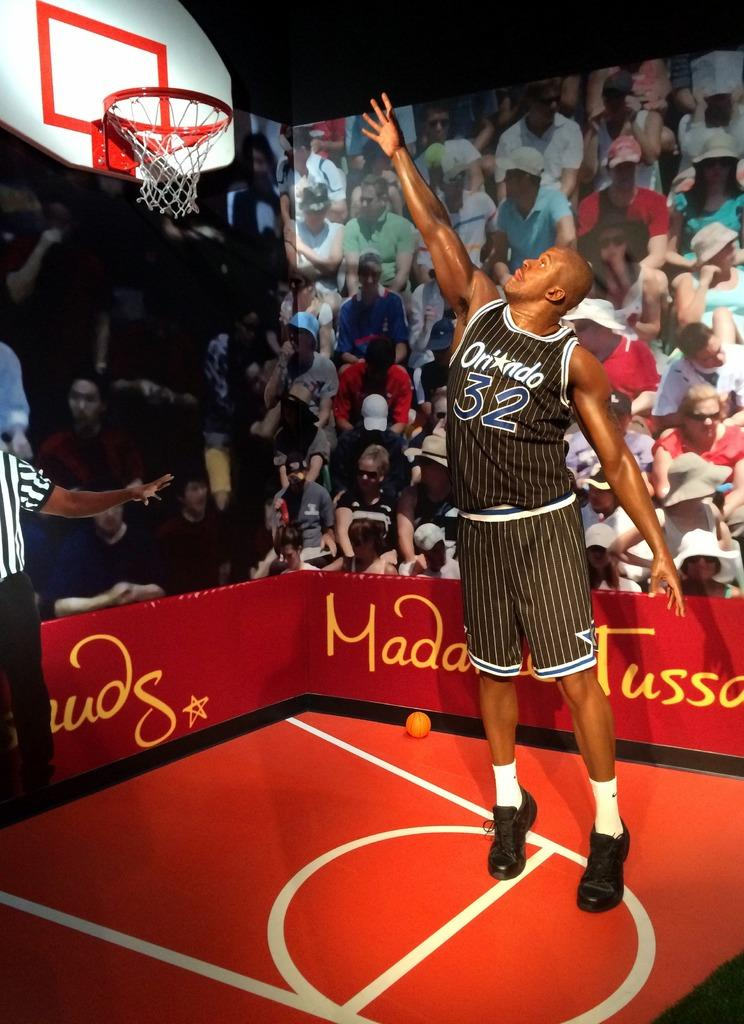What is the main subject of the image? There is a person standing in the center of the image. What can be seen in the background of the image? There is a board in the background of the image. What is located at the top of the image? There is a hoop at the top of the image. What is on the ground at the bottom of the image? There is a ball on the ground at the bottom of the image. What type of eggnog can be seen being poured into the hoop in the image? There is no eggnog present in the image; it features a person, a board, a hoop, and a ball. What kind of curve is visible in the image? There is no curve visible in the image; it features a person, a board, a hoop, and a ball. 